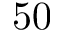<formula> <loc_0><loc_0><loc_500><loc_500>5 0</formula> 